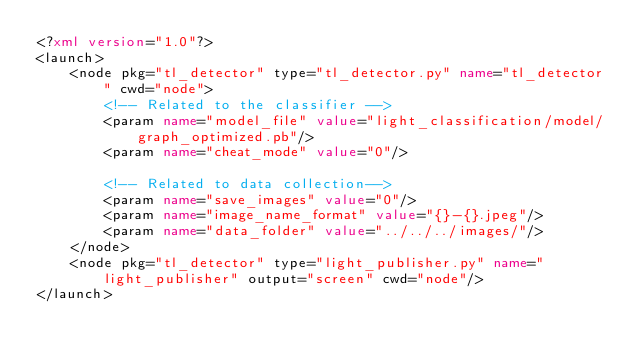<code> <loc_0><loc_0><loc_500><loc_500><_XML_><?xml version="1.0"?>
<launch>
    <node pkg="tl_detector" type="tl_detector.py" name="tl_detector" cwd="node">
        <!-- Related to the classifier -->
        <param name="model_file" value="light_classification/model/graph_optimized.pb"/>
        <param name="cheat_mode" value="0"/>

        <!-- Related to data collection-->
        <param name="save_images" value="0"/>
        <param name="image_name_format" value="{}-{}.jpeg"/>
        <param name="data_folder" value="../../../images/"/>
    </node>
    <node pkg="tl_detector" type="light_publisher.py" name="light_publisher" output="screen" cwd="node"/>
</launch>
</code> 